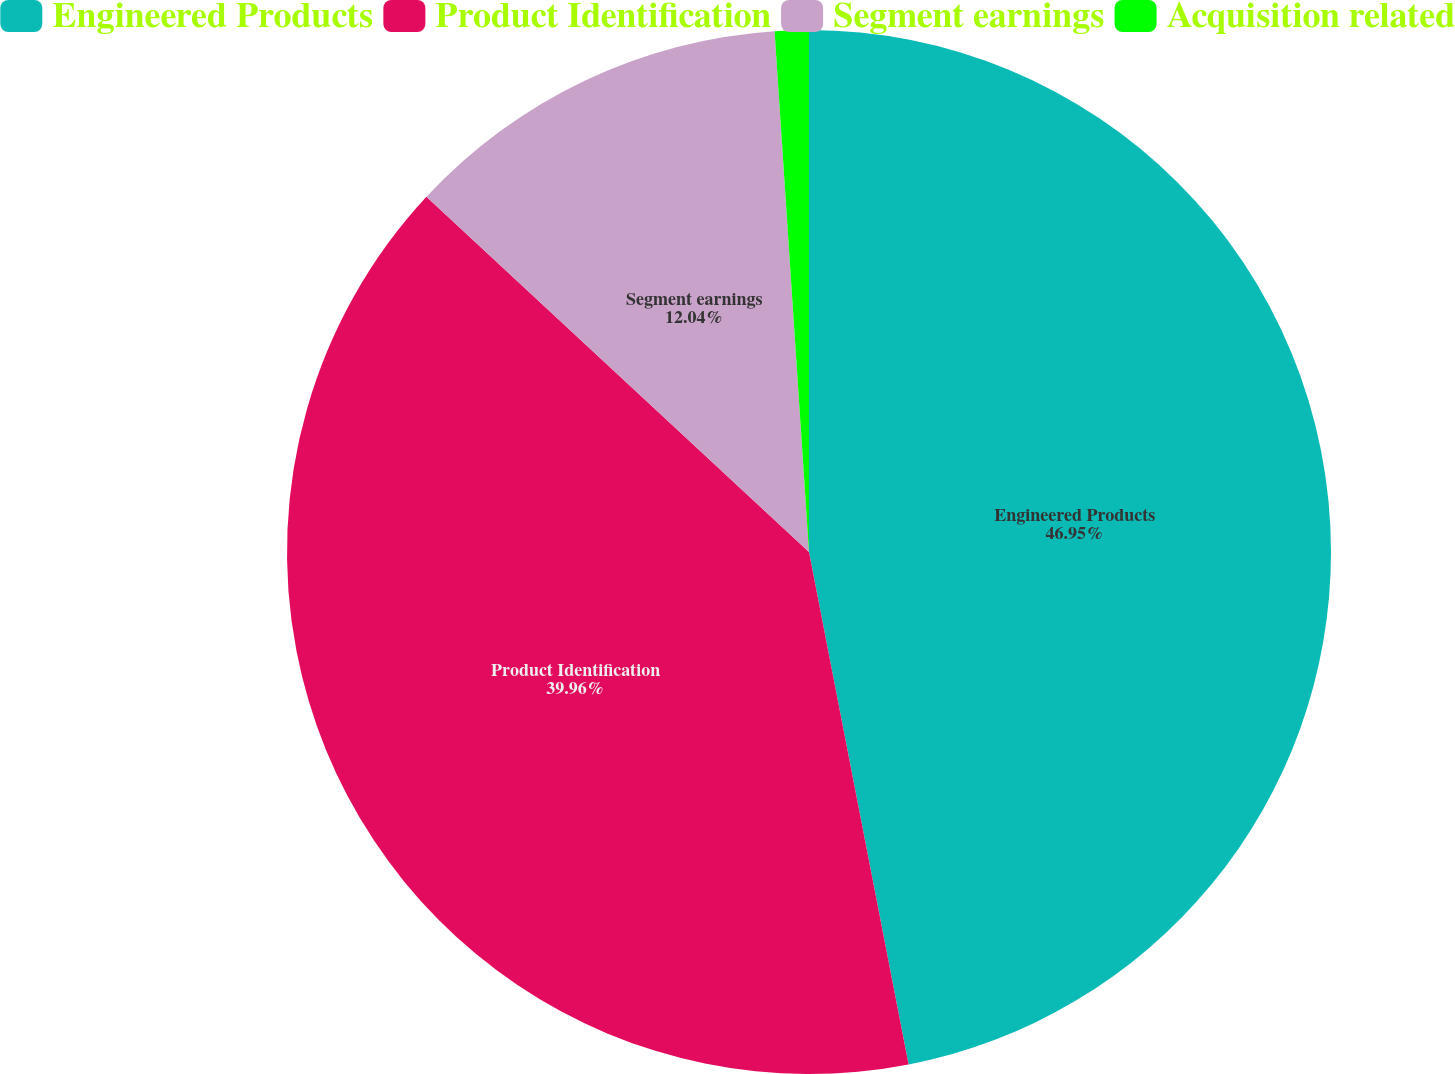<chart> <loc_0><loc_0><loc_500><loc_500><pie_chart><fcel>Engineered Products<fcel>Product Identification<fcel>Segment earnings<fcel>Acquisition related<nl><fcel>46.94%<fcel>39.96%<fcel>12.04%<fcel>1.05%<nl></chart> 